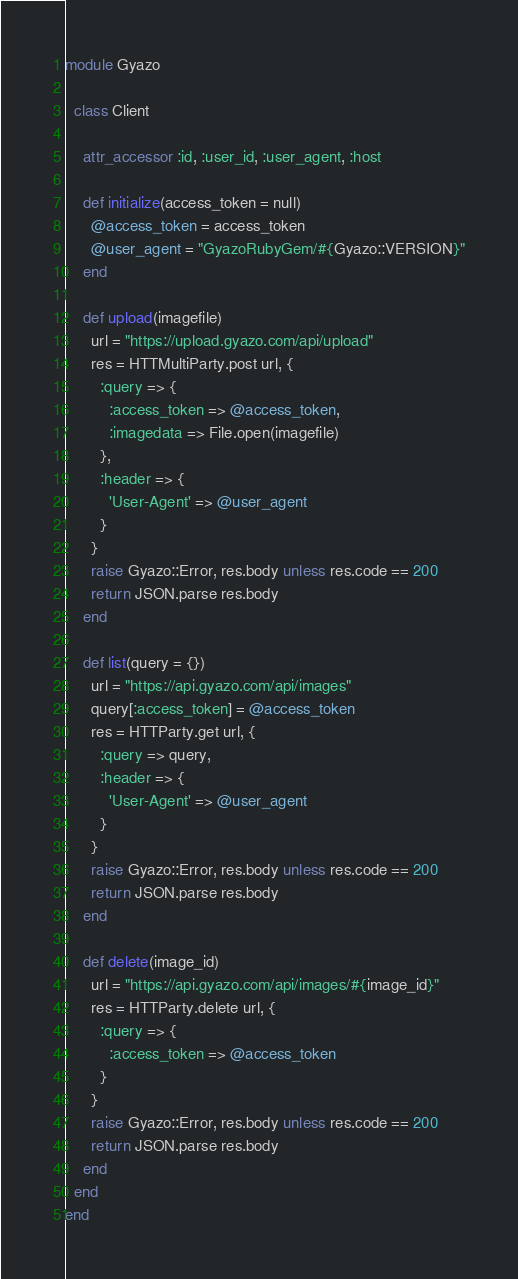Convert code to text. <code><loc_0><loc_0><loc_500><loc_500><_Ruby_>module Gyazo

  class Client

    attr_accessor :id, :user_id, :user_agent, :host

    def initialize(access_token = null)
      @access_token = access_token
      @user_agent = "GyazoRubyGem/#{Gyazo::VERSION}"
    end

    def upload(imagefile)
      url = "https://upload.gyazo.com/api/upload"
      res = HTTMultiParty.post url, {
        :query => {
          :access_token => @access_token,
          :imagedata => File.open(imagefile)
        },
        :header => {
          'User-Agent' => @user_agent
        }
      }
      raise Gyazo::Error, res.body unless res.code == 200
      return JSON.parse res.body
    end

    def list(query = {})
      url = "https://api.gyazo.com/api/images"
      query[:access_token] = @access_token
      res = HTTParty.get url, {
        :query => query,
        :header => {
          'User-Agent' => @user_agent
        }
      }
      raise Gyazo::Error, res.body unless res.code == 200
      return JSON.parse res.body
    end

    def delete(image_id)
      url = "https://api.gyazo.com/api/images/#{image_id}"
      res = HTTParty.delete url, {
        :query => {
          :access_token => @access_token
        }
      }
      raise Gyazo::Error, res.body unless res.code == 200
      return JSON.parse res.body
    end
  end
end
</code> 